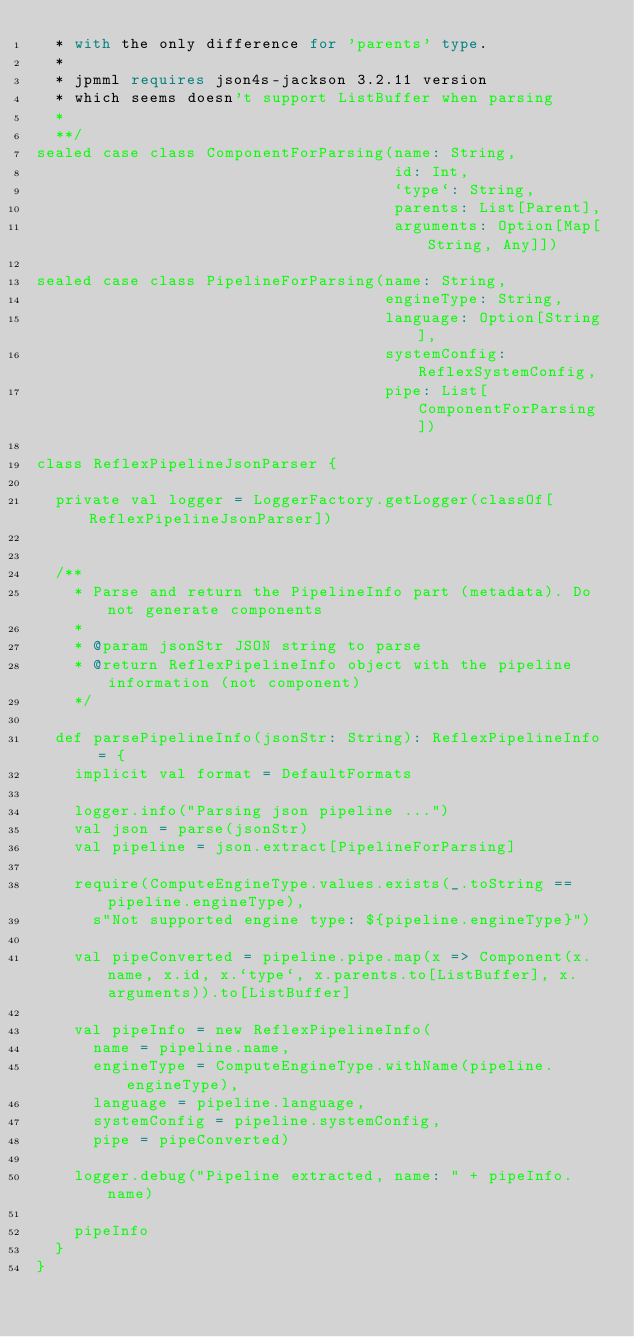<code> <loc_0><loc_0><loc_500><loc_500><_Scala_>  * with the only difference for 'parents' type.
  *
  * jpmml requires json4s-jackson 3.2.11 version
  * which seems doesn't support ListBuffer when parsing
  *
  **/
sealed case class ComponentForParsing(name: String,
                                      id: Int,
                                      `type`: String,
                                      parents: List[Parent],
                                      arguments: Option[Map[String, Any]])

sealed case class PipelineForParsing(name: String,
                                     engineType: String,
                                     language: Option[String],
                                     systemConfig: ReflexSystemConfig,
                                     pipe: List[ComponentForParsing])

class ReflexPipelineJsonParser {

  private val logger = LoggerFactory.getLogger(classOf[ReflexPipelineJsonParser])


  /**
    * Parse and return the PipelineInfo part (metadata). Do not generate components
    *
    * @param jsonStr JSON string to parse
    * @return ReflexPipelineInfo object with the pipeline information (not component)
    */

  def parsePipelineInfo(jsonStr: String): ReflexPipelineInfo = {
    implicit val format = DefaultFormats

    logger.info("Parsing json pipeline ...")
    val json = parse(jsonStr)
    val pipeline = json.extract[PipelineForParsing]

    require(ComputeEngineType.values.exists(_.toString == pipeline.engineType),
      s"Not supported engine type: ${pipeline.engineType}")

    val pipeConverted = pipeline.pipe.map(x => Component(x.name, x.id, x.`type`, x.parents.to[ListBuffer], x.arguments)).to[ListBuffer]

    val pipeInfo = new ReflexPipelineInfo(
      name = pipeline.name,
      engineType = ComputeEngineType.withName(pipeline.engineType),
      language = pipeline.language,
      systemConfig = pipeline.systemConfig,
      pipe = pipeConverted)

    logger.debug("Pipeline extracted, name: " + pipeInfo.name)

    pipeInfo
  }
}
</code> 